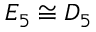Convert formula to latex. <formula><loc_0><loc_0><loc_500><loc_500>E _ { 5 } \cong D _ { 5 }</formula> 